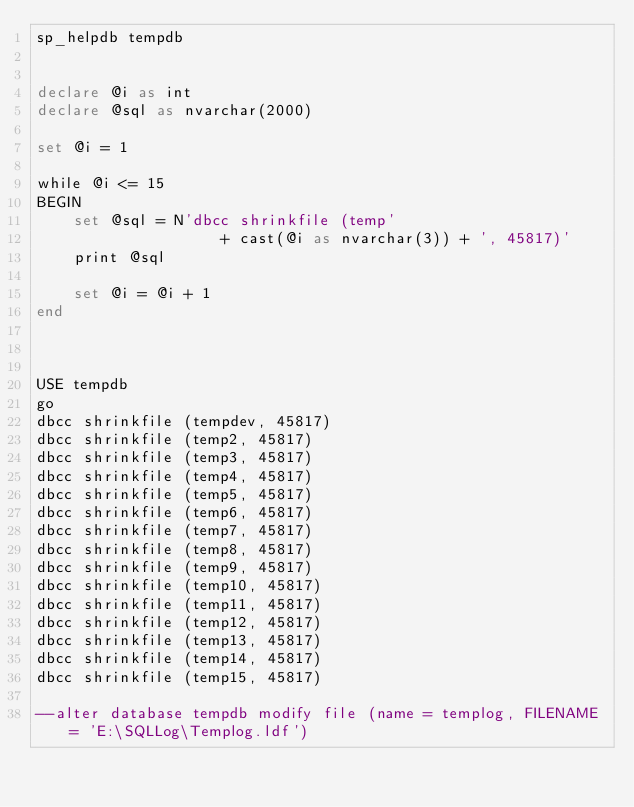<code> <loc_0><loc_0><loc_500><loc_500><_SQL_>sp_helpdb tempdb


declare @i as int
declare @sql as nvarchar(2000)

set @i = 1

while @i <= 15
BEGIN
	set @sql = N'dbcc shrinkfile (temp' 
					+ cast(@i as nvarchar(3)) + ', 45817)'
	print @sql
	
	set @i = @i + 1
end



USE tempdb
go
dbcc shrinkfile (tempdev, 45817)
dbcc shrinkfile (temp2, 45817)
dbcc shrinkfile (temp3, 45817)
dbcc shrinkfile (temp4, 45817)
dbcc shrinkfile (temp5, 45817)
dbcc shrinkfile (temp6, 45817)
dbcc shrinkfile (temp7, 45817)
dbcc shrinkfile (temp8, 45817)
dbcc shrinkfile (temp9, 45817)
dbcc shrinkfile (temp10, 45817)
dbcc shrinkfile (temp11, 45817)
dbcc shrinkfile (temp12, 45817)
dbcc shrinkfile (temp13, 45817)
dbcc shrinkfile (temp14, 45817)
dbcc shrinkfile (temp15, 45817)

--alter database tempdb modify file (name = templog, FILENAME = 'E:\SQLLog\Templog.ldf')



</code> 